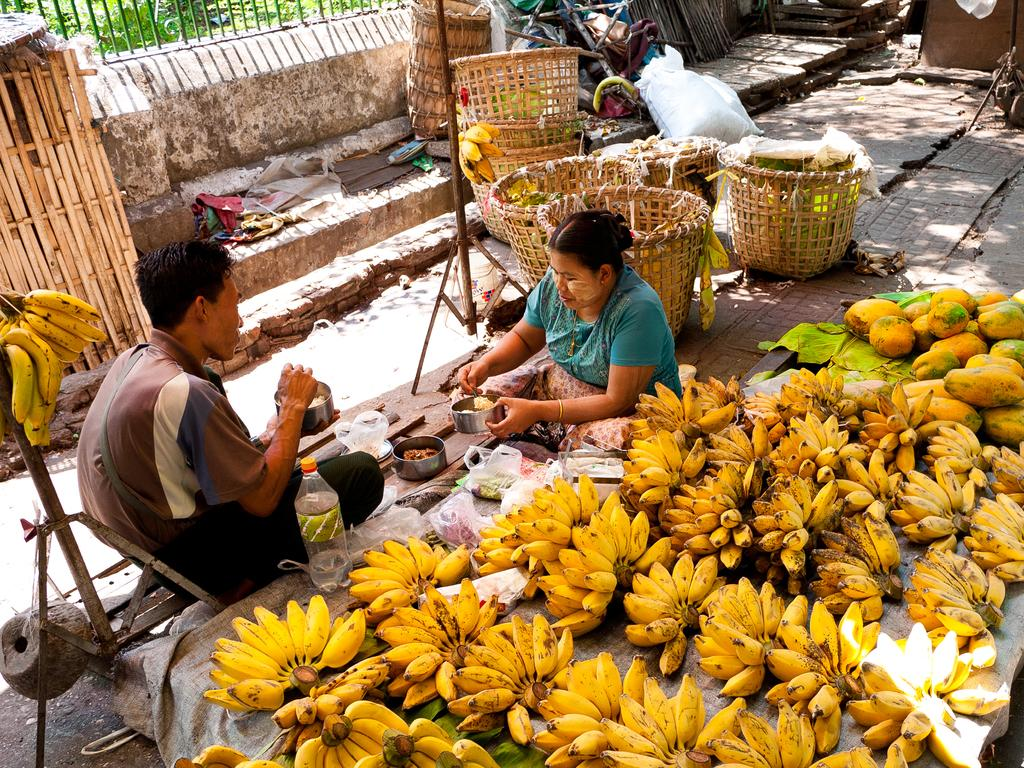What type of fruits can be seen in the image? There are bananas and papayas in the image. How are the bananas and papayas arranged in the image? The bananas and papayas are kept on the floor in the image. Who is present in the image? There is a man and a woman in the image. What are the man and woman doing in the image? The man and woman are having food in the image. What type of containers are visible in the image? There are wooden baskets in the image. What other items can be seen in the image? There are other items visible in the image, but their specific details are not mentioned in the provided facts. What type of wren can be seen in the image? There is no wren present in the image; it features bananas, papayas, a man, a woman, and wooden baskets. Is the dirt visible in the image? The provided facts do not mention any dirt in the image, so it cannot be determined from the information given. 